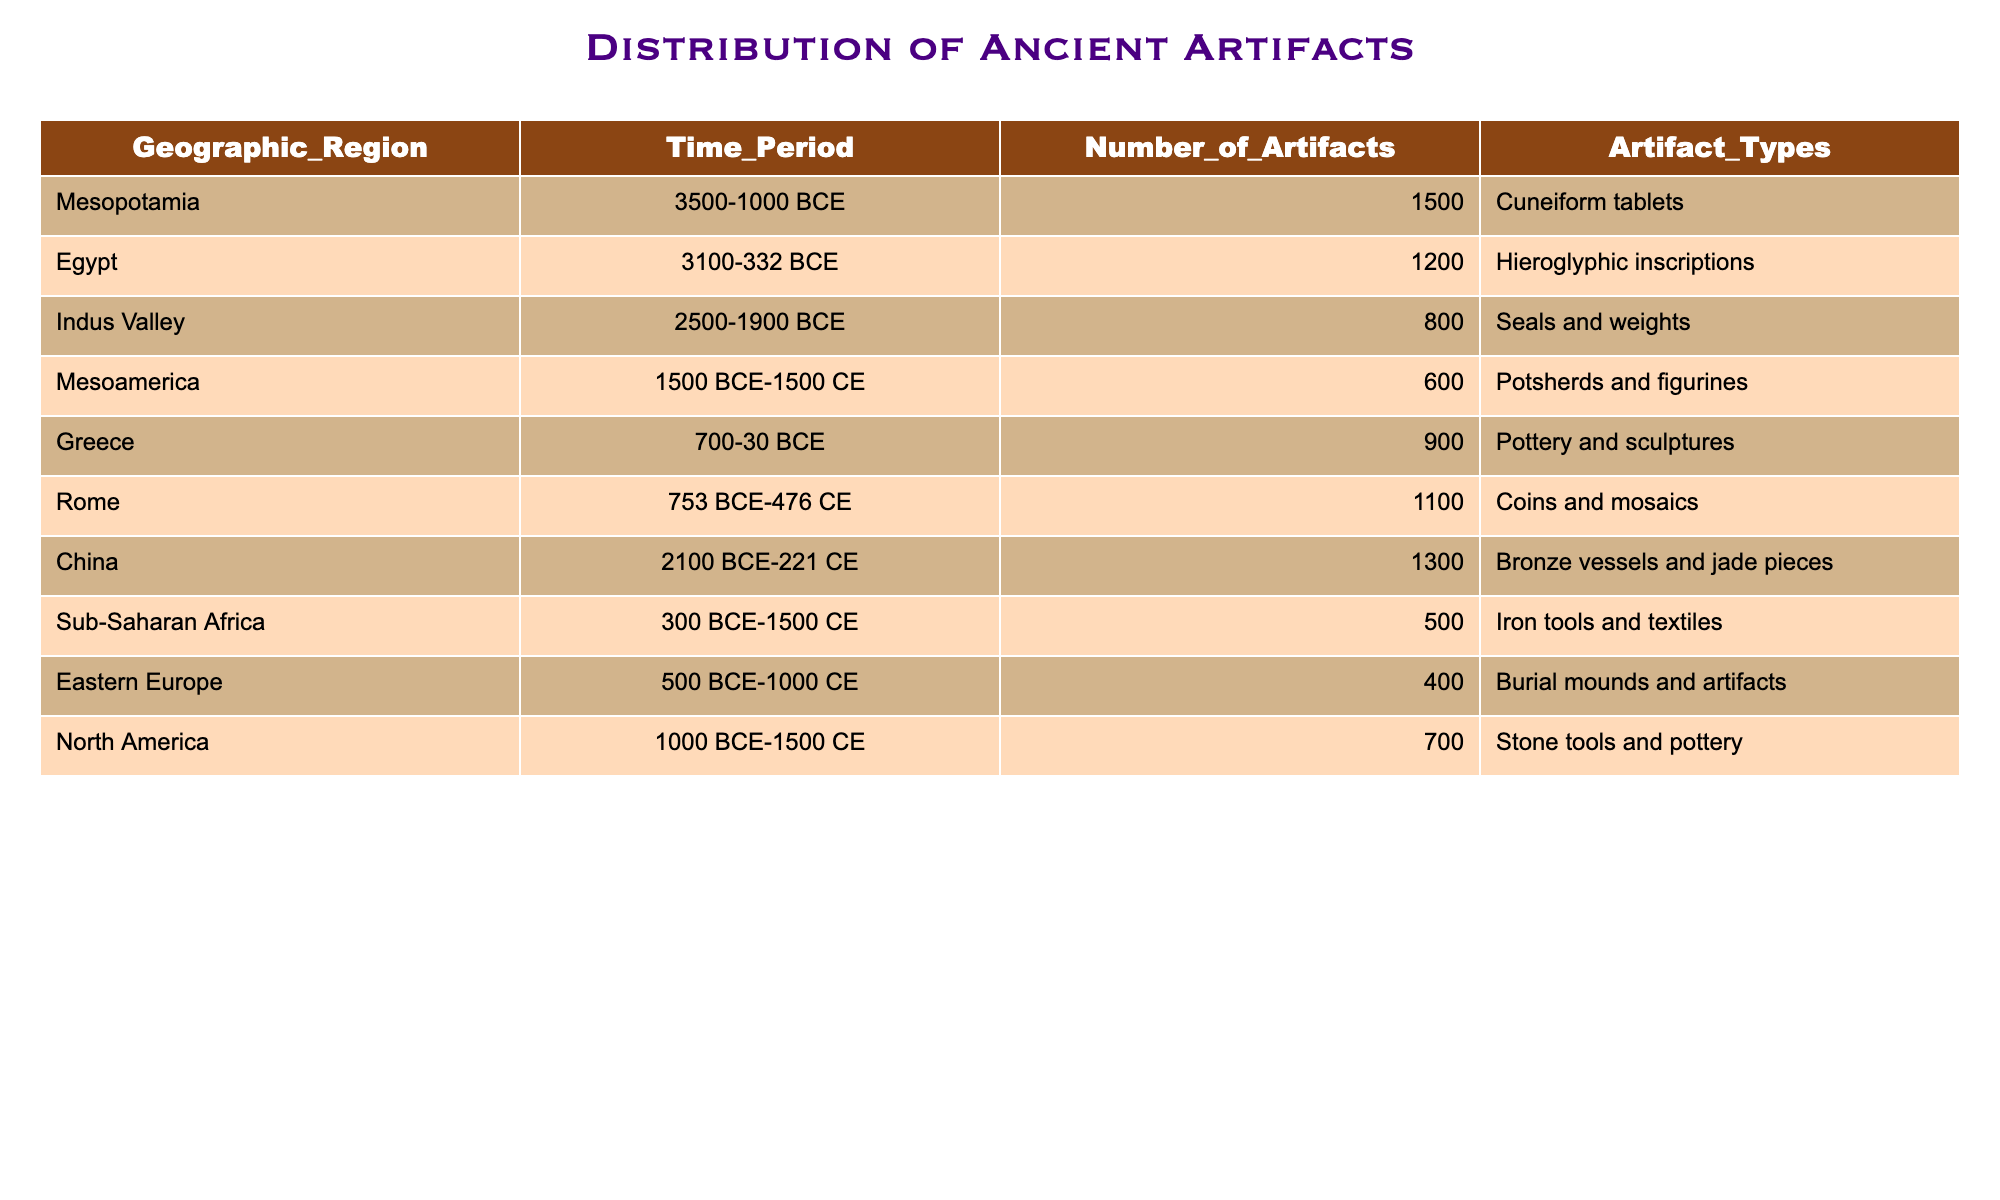What is the highest number of artifacts recorded in a single geographic region? The table shows the number of artifacts for each geographic region. The maximum value is 1500 artifacts in Mesopotamia.
Answer: 1500 How many artifact types are specified for ancient artifacts in the table? The list of artifact types includes Cuneiform tablets, Hieroglyphic inscriptions, Seals and weights, Potsherds and figurines, Pottery and sculptures, Coins and mosaics, Bronze vessels and jade pieces, Iron tools and textiles, Burial mounds and artifacts, Stone tools and pottery. Counting these gives 10 distinct types.
Answer: 10 Which regions have more than 1000 artifacts? By examining the table, the regions with more than 1000 artifacts are Mesopotamia (1500), China (1300), and Rome (1100), totaling three regions.
Answer: 3 What is the total number of artifacts found in Mesoamerica and North America combined? The number of artifacts in Mesoamerica is 600 and in North America is 700. Adding these numbers together gives 600 + 700 = 1300 artifacts in total for both regions.
Answer: 1300 Are there any regions with less than 500 artifacts? Looking at the table, Sub-Saharan Africa has 500 artifacts, while Eastern Europe has 400 artifacts. Since Eastern Europe is less than 500, the answer is yes, there is at least one region with less than 500 artifacts.
Answer: Yes Which time period corresponds to the largest collection of artifacts, and how many artifacts does it have? The time periods can be correlated with the artifact counts. Mesopotamia in the time period of 3500-1000 BCE has the highest count at 1500 artifacts. This confirms that it also corresponds to the largest collection.
Answer: 1500 in 3500-1000 BCE What is the average number of artifacts across all geographic regions listed? To find the average, add the total number of artifacts: 1500 + 1200 + 800 + 600 + 900 + 1100 + 1300 + 500 + 400 + 700 = 6100. There are 10 regions, so the average is 6100 / 10 = 610 artifacts.
Answer: 610 How many artifact types does Greece have, and what are they? From the table, Greece has one artifact type listed, which is Pottery and sculptures. This indicates that Greece has only one specified type of artifacts.
Answer: 1, Pottery and sculptures Which region has the least number of artifacts, and how many are there? By reviewing the table, Eastern Europe has the least number of artifacts at 400. Thus, it can be concluded that this is the region with the least artifacts.
Answer: Eastern Europe, 400 